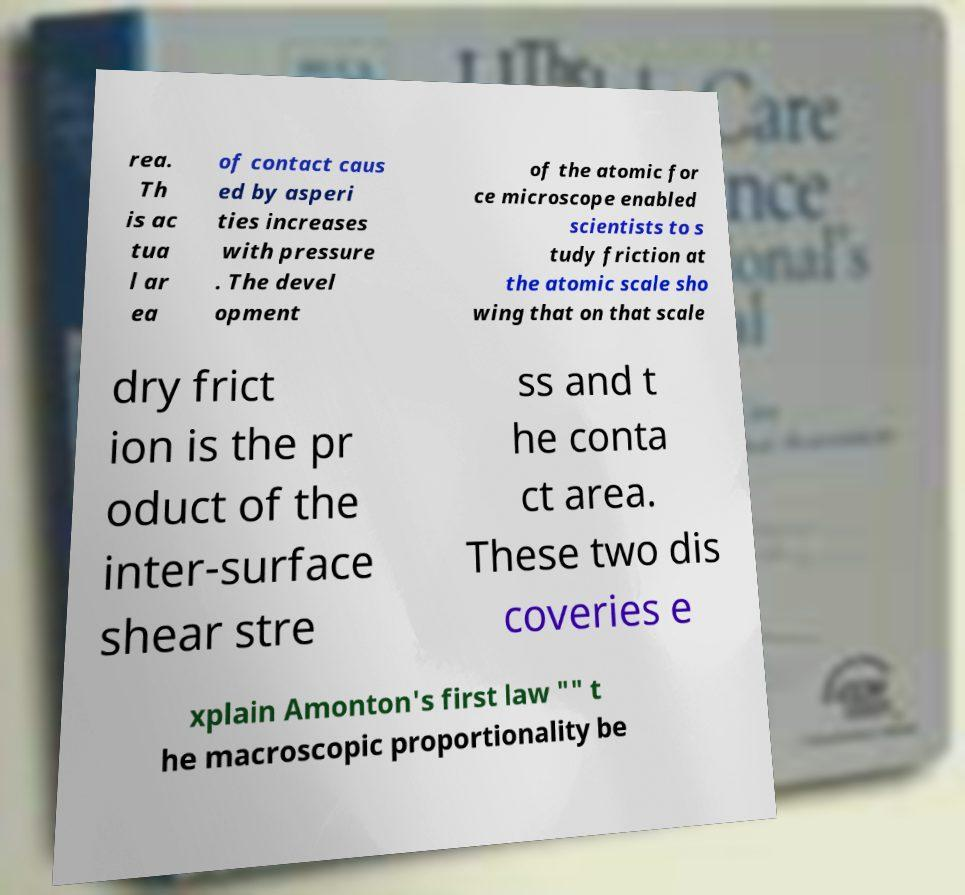Can you accurately transcribe the text from the provided image for me? rea. Th is ac tua l ar ea of contact caus ed by asperi ties increases with pressure . The devel opment of the atomic for ce microscope enabled scientists to s tudy friction at the atomic scale sho wing that on that scale dry frict ion is the pr oduct of the inter-surface shear stre ss and t he conta ct area. These two dis coveries e xplain Amonton's first law "" t he macroscopic proportionality be 